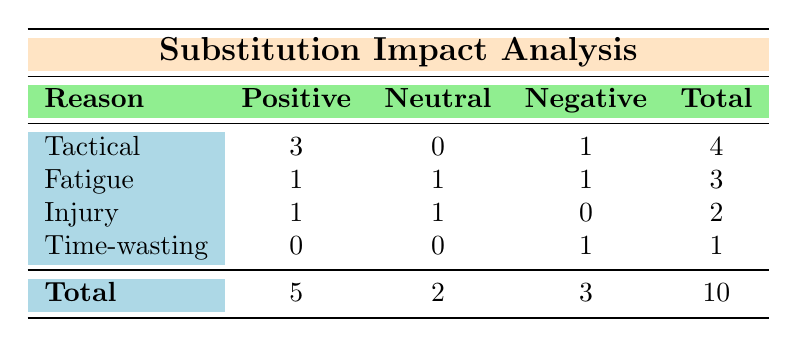What is the total count of substitutions listed in the table? To find the total count of substitutions, we look at the last row in the table that indicates the total. It states a total of 10 substitutions.
Answer: 10 How many substitutions had a positive impact? The table shows that under the "Positive" column, there are 5 instances of substitutions that positively impacted the game.
Answer: 5 Was there any substitution due to time-wasting? The table indicates that there was 1 substitution categorized under the reason "Time-wasting," leading to a negative impact.
Answer: Yes What is the impact of substitutions made due to fatigue? According to the table, 1 substitution due to fatigue had a positive impact, while another had a neutral impact, and 1 had a negative impact.
Answer: Positive: 1, Neutral: 1, Negative: 1 What is the total number of substitutions categorized as tactical? The table indicates that there are 4 total substitutions listed as tactical, with 3 having a positive impact and 1 having a negative impact.
Answer: 4 How many total substitutions resulted in a negative impact? In the "Negative" column, the table shows a total of 3 substitutions that had a negative impact on the game results.
Answer: 3 If we look at the total positive impacts versus negative impacts, what is the difference? The table lists 5 positive impacts and 3 negative impacts. Therefore, the difference is calculated as 5 - 3 = 2.
Answer: 2 Were there more substitutions due to tactical reasons or injury? The table shows 4 substitutions for tactical reasons and 2 from injuries. Therefore, there were more substitutions for tactical reasons.
Answer: Tactical reasons What percentage of the total substitutions had a neutral impact? The table indicates there were 10 total substitutions and 2 had a neutral impact. The percentage is calculated as (2/10) * 100 = 20%.
Answer: 20% How do the tactical substitutions compare to those caused by injury in terms of positive outcomes? The table shows that out of 4 tactical substitutions, 3 had a positive impact, while from 2 substitutions due to injury, only 1 had a positive impact. The ratio indicates a higher success rate for tactical substitutions.
Answer: Tactical: 3 positive; Injury: 1 positive 